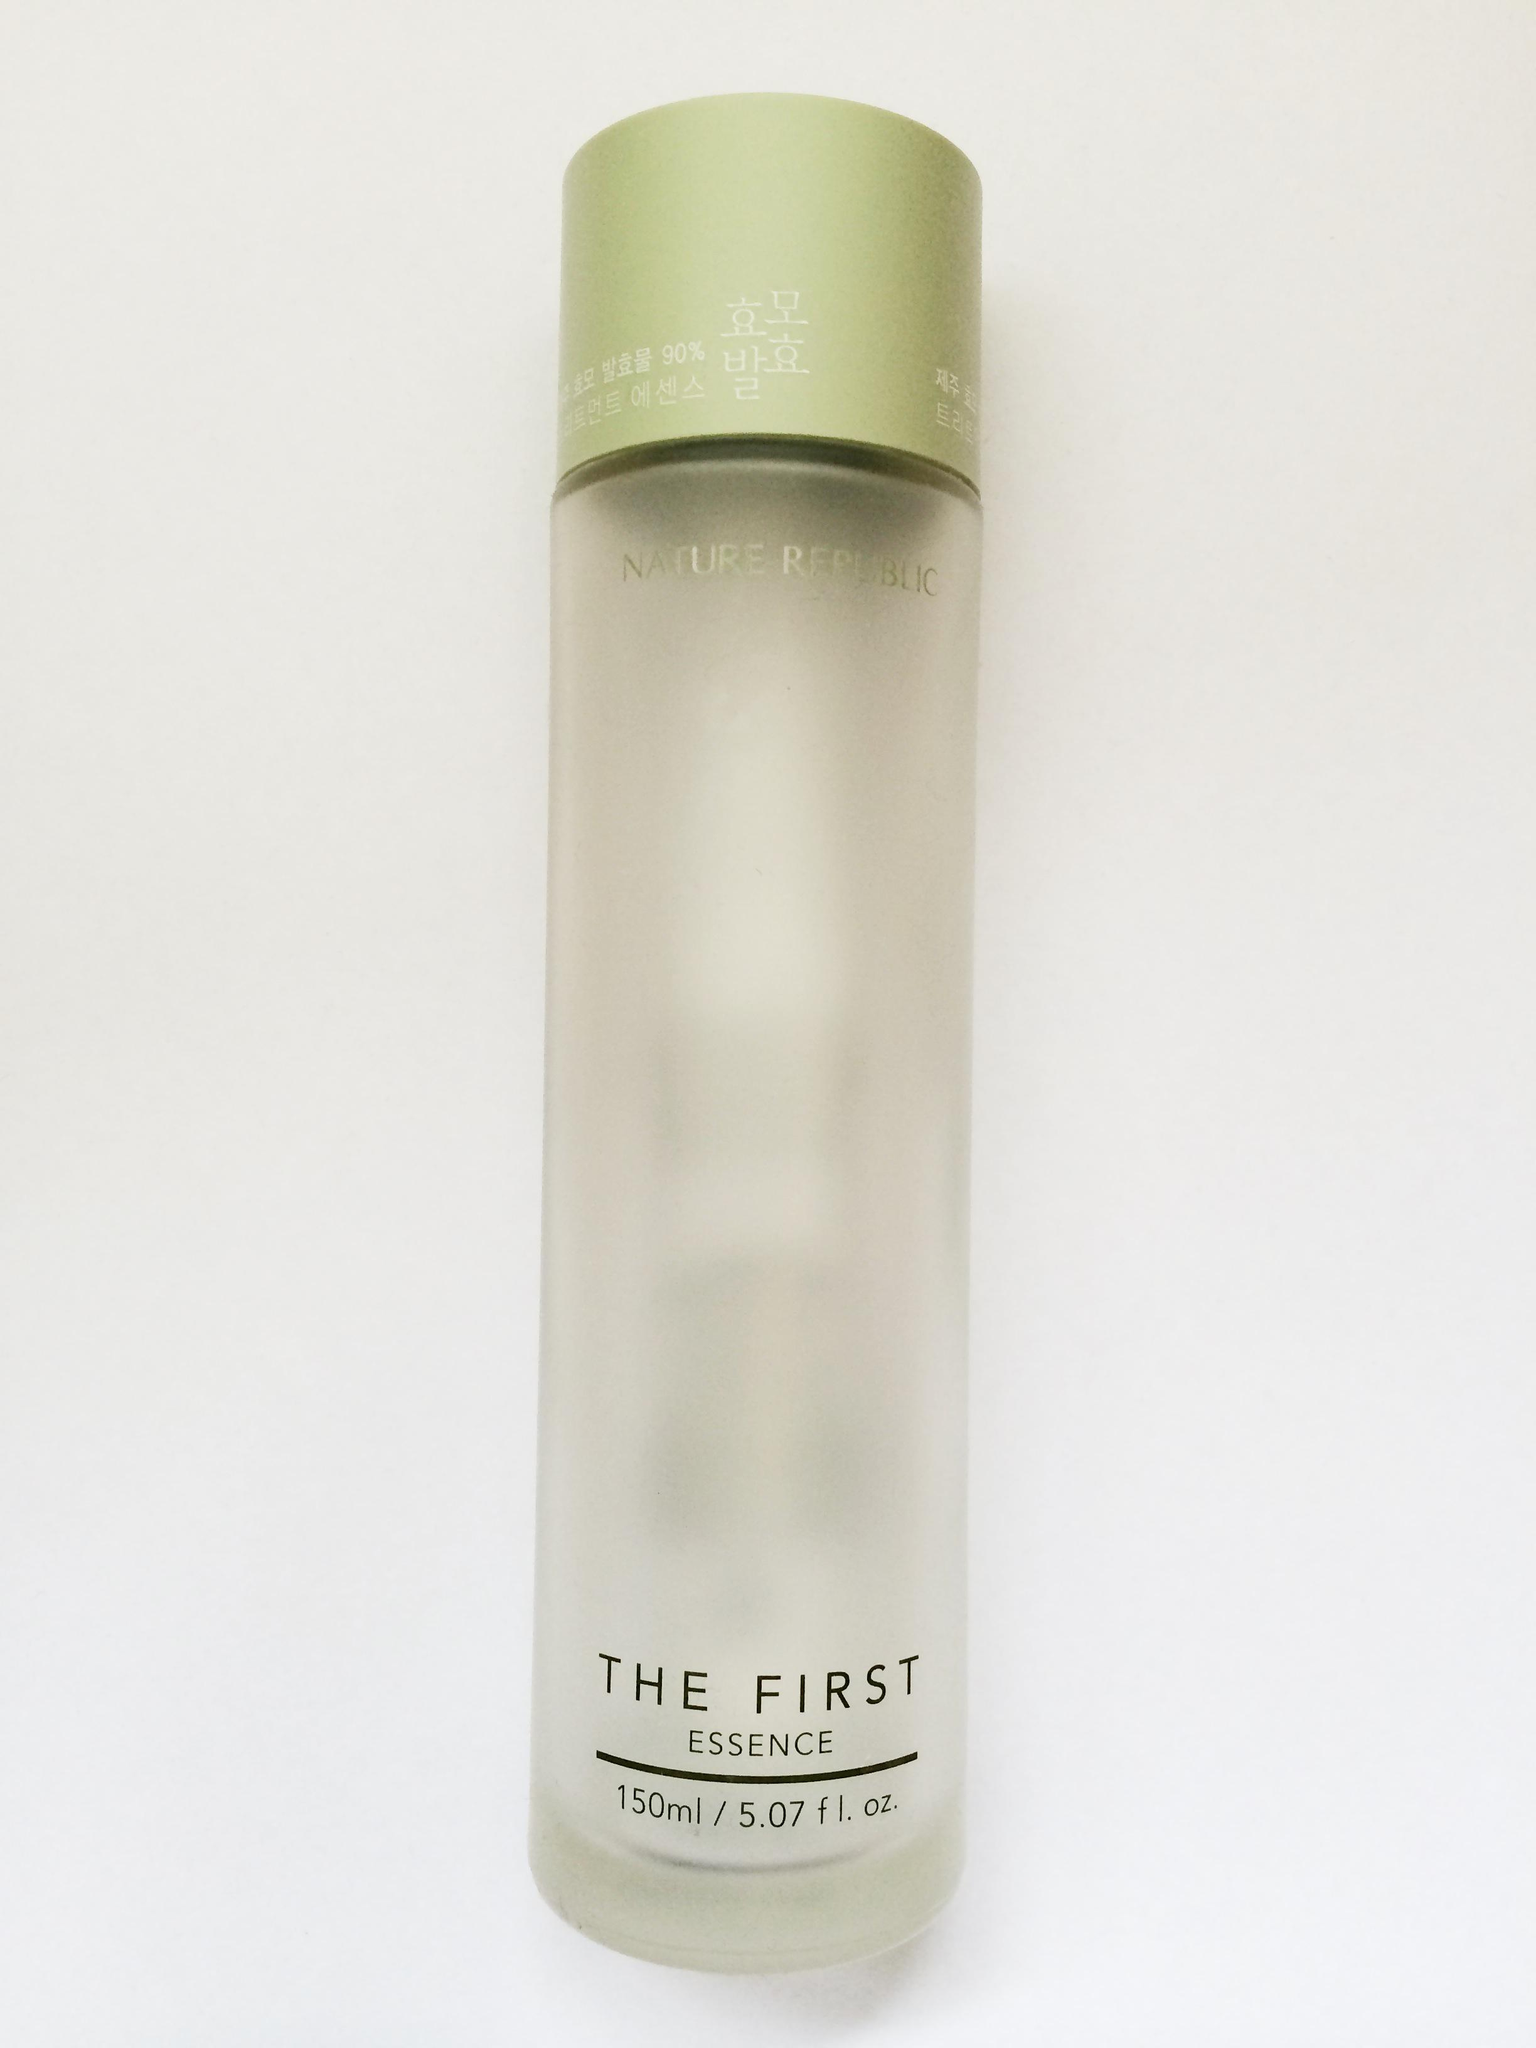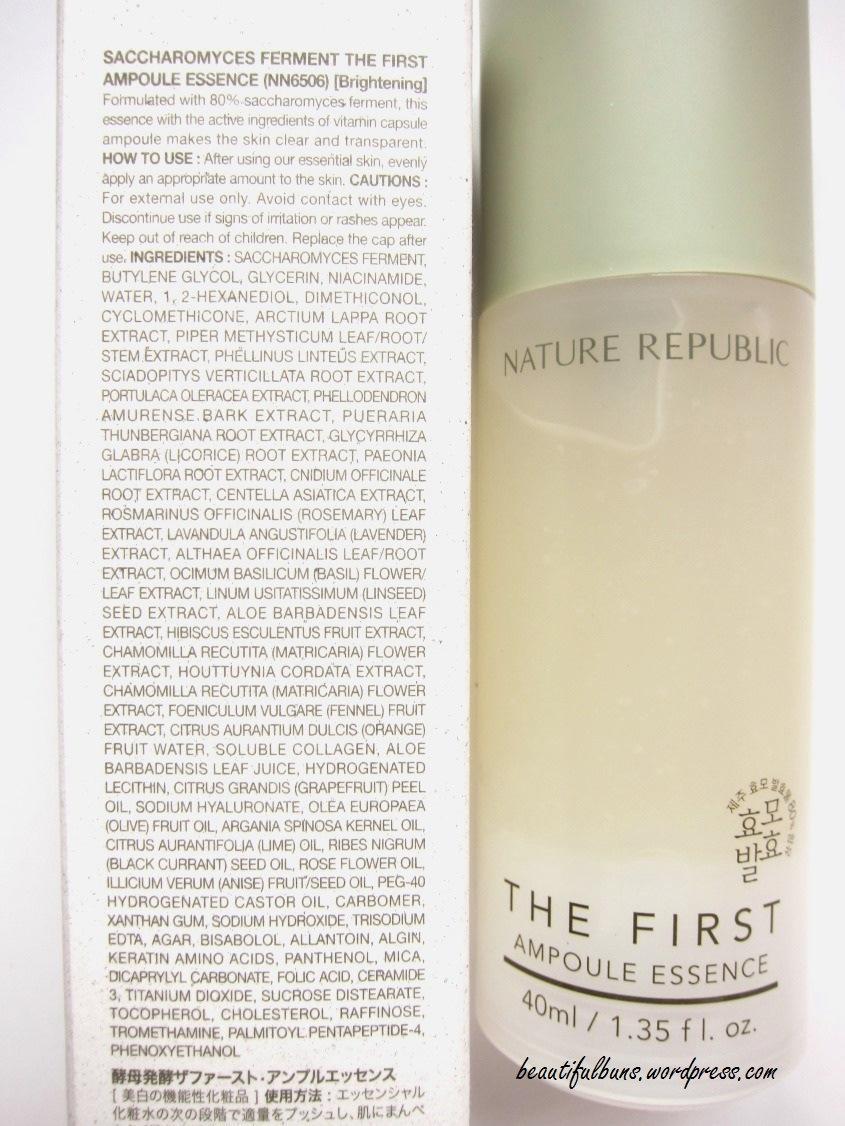The first image is the image on the left, the second image is the image on the right. Analyze the images presented: Is the assertion "The left image contains one fragrance bottle standing alone, and the right image contains a fragrance bottle to the right of its box." valid? Answer yes or no. Yes. The first image is the image on the left, the second image is the image on the right. Considering the images on both sides, is "At least one bottle in the image on the left has a silver cap." valid? Answer yes or no. No. 